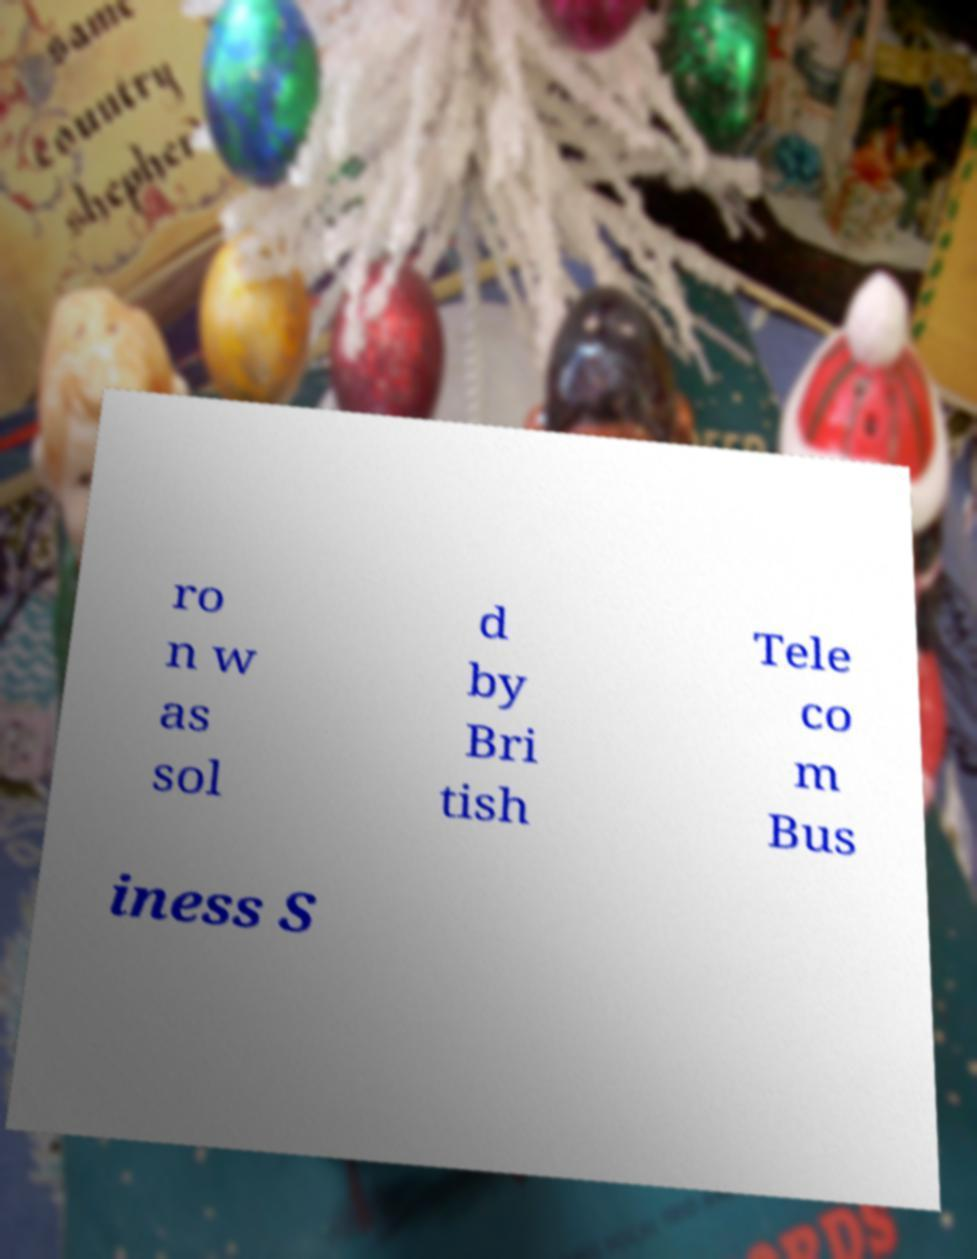Please identify and transcribe the text found in this image. ro n w as sol d by Bri tish Tele co m Bus iness S 